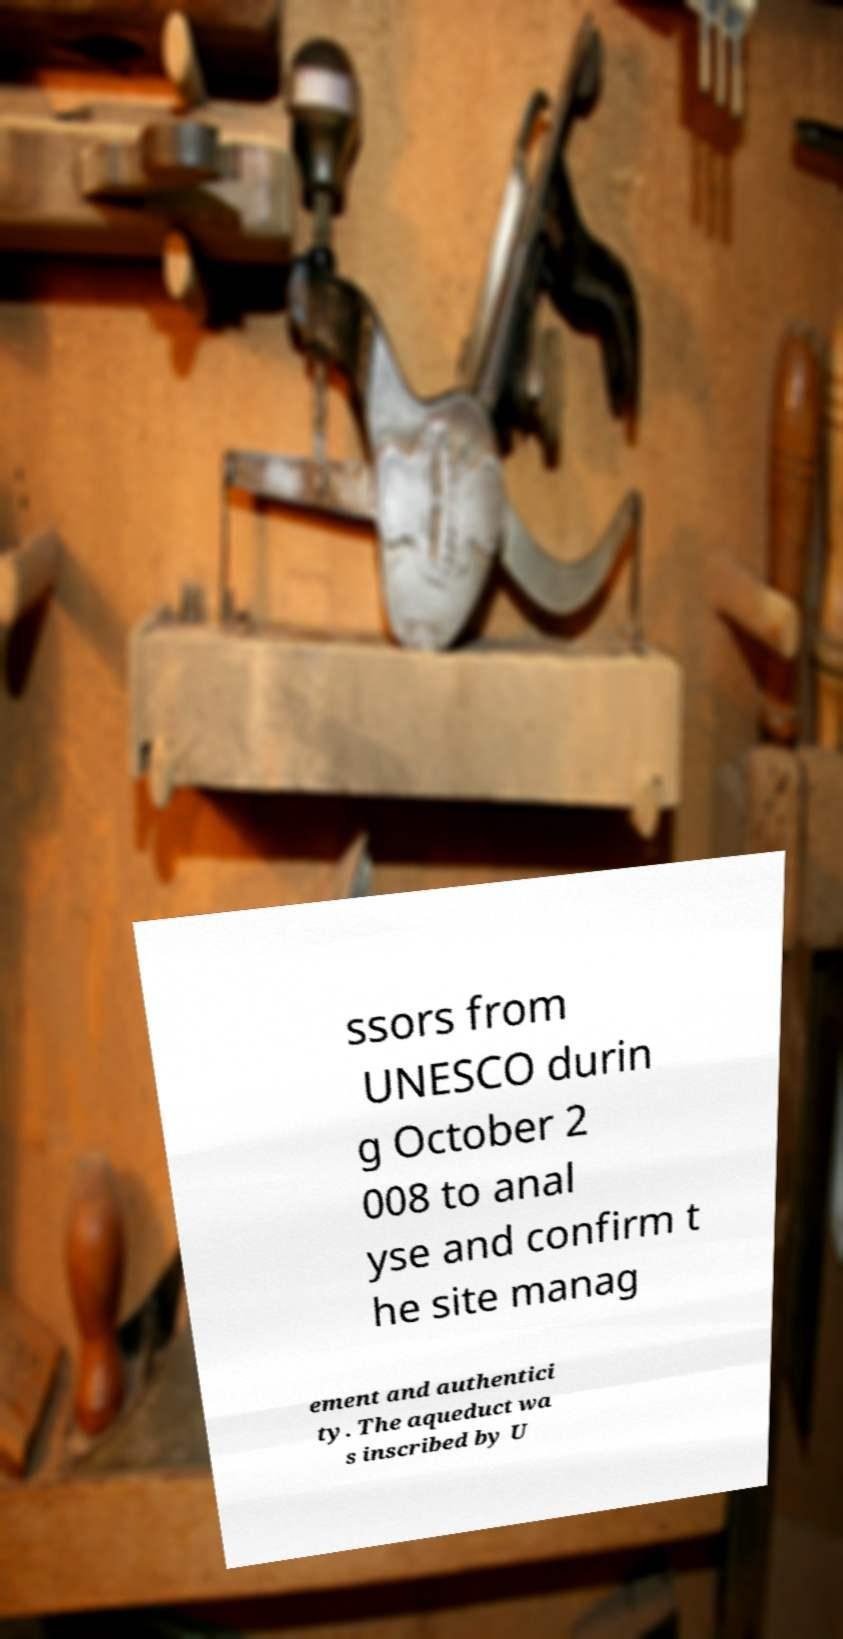What messages or text are displayed in this image? I need them in a readable, typed format. ssors from UNESCO durin g October 2 008 to anal yse and confirm t he site manag ement and authentici ty. The aqueduct wa s inscribed by U 